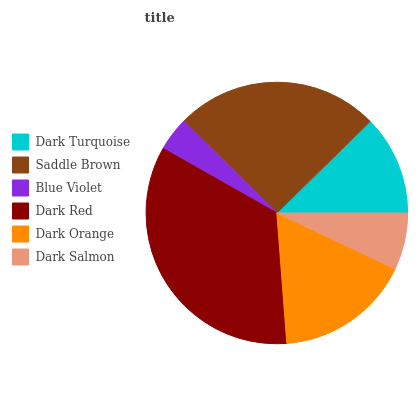Is Blue Violet the minimum?
Answer yes or no. Yes. Is Dark Red the maximum?
Answer yes or no. Yes. Is Saddle Brown the minimum?
Answer yes or no. No. Is Saddle Brown the maximum?
Answer yes or no. No. Is Saddle Brown greater than Dark Turquoise?
Answer yes or no. Yes. Is Dark Turquoise less than Saddle Brown?
Answer yes or no. Yes. Is Dark Turquoise greater than Saddle Brown?
Answer yes or no. No. Is Saddle Brown less than Dark Turquoise?
Answer yes or no. No. Is Dark Orange the high median?
Answer yes or no. Yes. Is Dark Turquoise the low median?
Answer yes or no. Yes. Is Dark Salmon the high median?
Answer yes or no. No. Is Saddle Brown the low median?
Answer yes or no. No. 